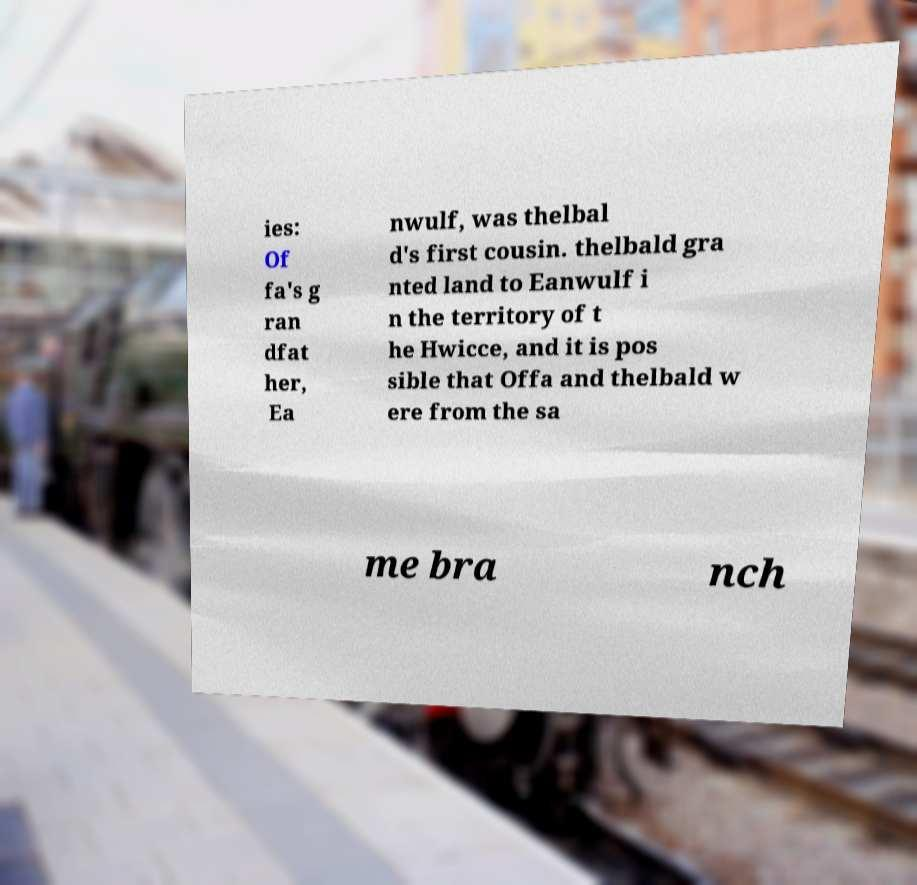Can you read and provide the text displayed in the image?This photo seems to have some interesting text. Can you extract and type it out for me? ies: Of fa's g ran dfat her, Ea nwulf, was thelbal d's first cousin. thelbald gra nted land to Eanwulf i n the territory of t he Hwicce, and it is pos sible that Offa and thelbald w ere from the sa me bra nch 